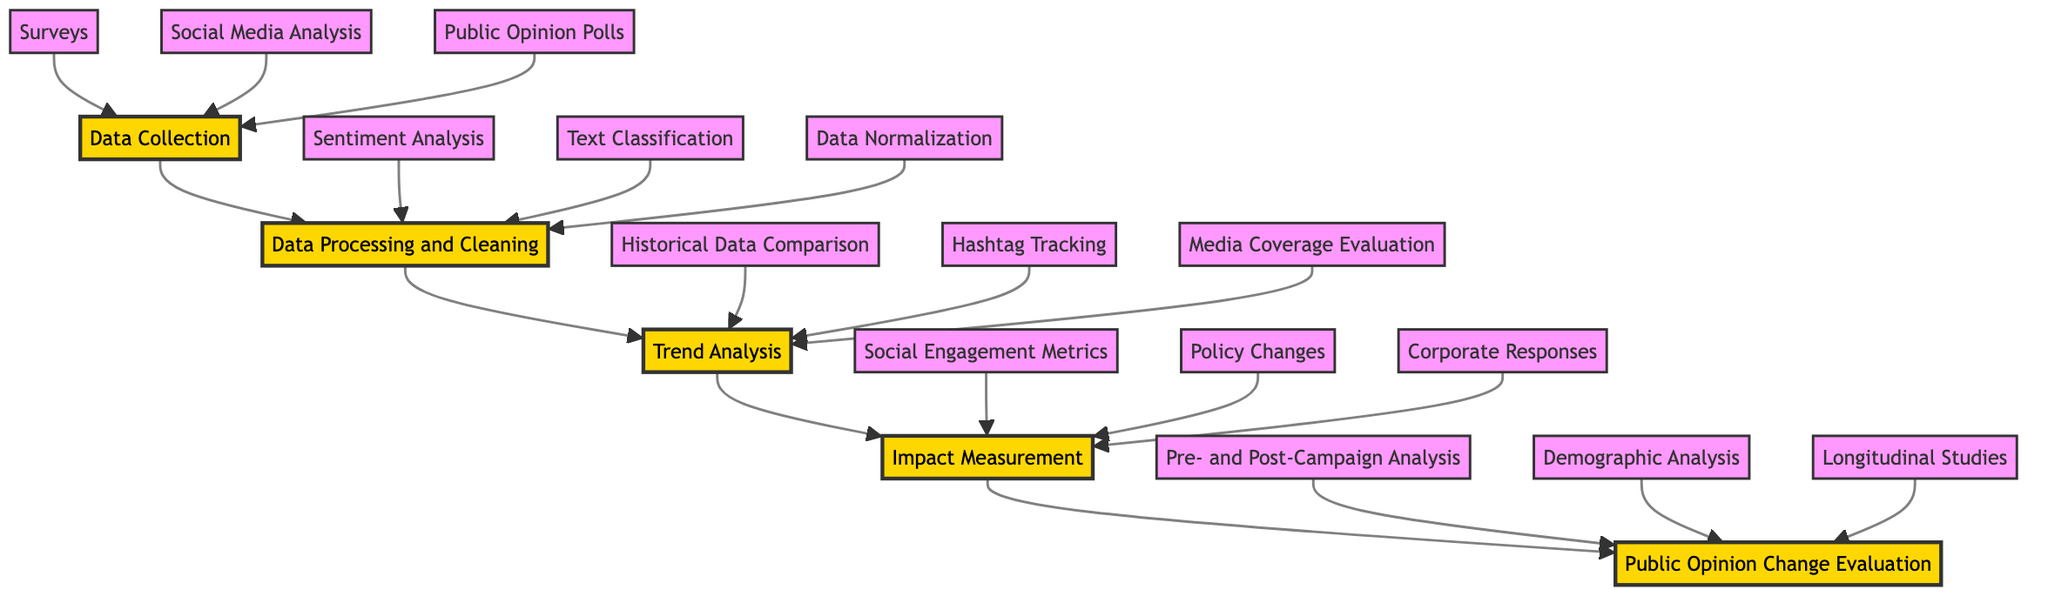What is the first node in the flowchart? The first node is "Data Collection," seen at the bottom of the flowchart. It is the starting point of the process, leading to the next step.
Answer: Data Collection How many sub-elements are under "Impact Measurement"? There are three sub-elements listed under "Impact Measurement": Social Engagement Metrics, Policy Changes, and Corporate Responses. Counting them gives a total of three sub-elements.
Answer: 3 Which node follows "Trend Analysis"? The node that follows "Trend Analysis" is "Impact Measurement." The flowchart shows a direct connection from Trend Analysis to Impact Measurement, indicating that it is the next step in the process.
Answer: Impact Measurement What type of analysis is done after Data Processing and Cleaning? Following Data Processing and Cleaning, "Trend Analysis" is performed. This node is directly connected, indicating it's the next process after cleaning the data.
Answer: Trend Analysis What is the last step in the flowchart? The last step in the flowchart is "Public Opinion Change Evaluation." It is the topmost node in the flow, concluding the entire evaluation process for public opinions.
Answer: Public Opinion Change Evaluation What are the main methods listed for Data Collection? The methods listed for Data Collection are Surveys, Social Media Analysis, and Public Opinion Polls. These are shown as sub-elements beneath the Data Collection node in the flowchart.
Answer: Surveys, Social Media Analysis, Public Opinion Polls What is the relationship between "Data Processing and Cleaning" and "Public Opinion Change Evaluation"? "Data Processing and Cleaning" is a prerequisite step that must be completed before moving on to "Public Opinion Change Evaluation." This sequential flow illustrates a progressive analysis approach of public opinions after data is processed.
Answer: Prerequisite How many main nodes are there in the flowchart? The flowchart has five main nodes: Data Collection, Data Processing and Cleaning, Trend Analysis, Impact Measurement, and Public Opinion Change Evaluation, which are the key steps in the evaluation process.
Answer: 5 What sub-element follows "Sentiment Analysis"? There is no sub-element that follows "Sentiment Analysis" directly. It is one of the three sub-elements listed under "Data Processing and Cleaning," all of which are parallel to each other.
Answer: None 